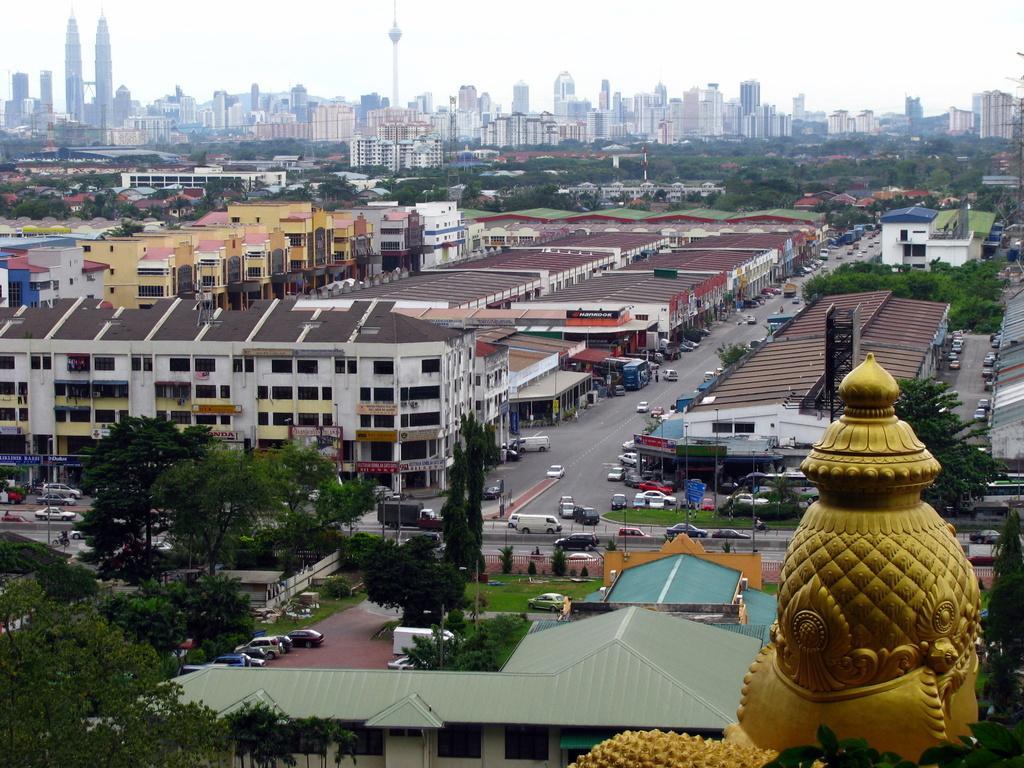Describe this image in one or two sentences. In this image I can see on the left side there are trees, in the middle few vehicles are moving on the road and there are buildings. At the top it is the sky, on the right side it looks like a statue. 